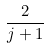<formula> <loc_0><loc_0><loc_500><loc_500>\frac { 2 } { j + 1 }</formula> 